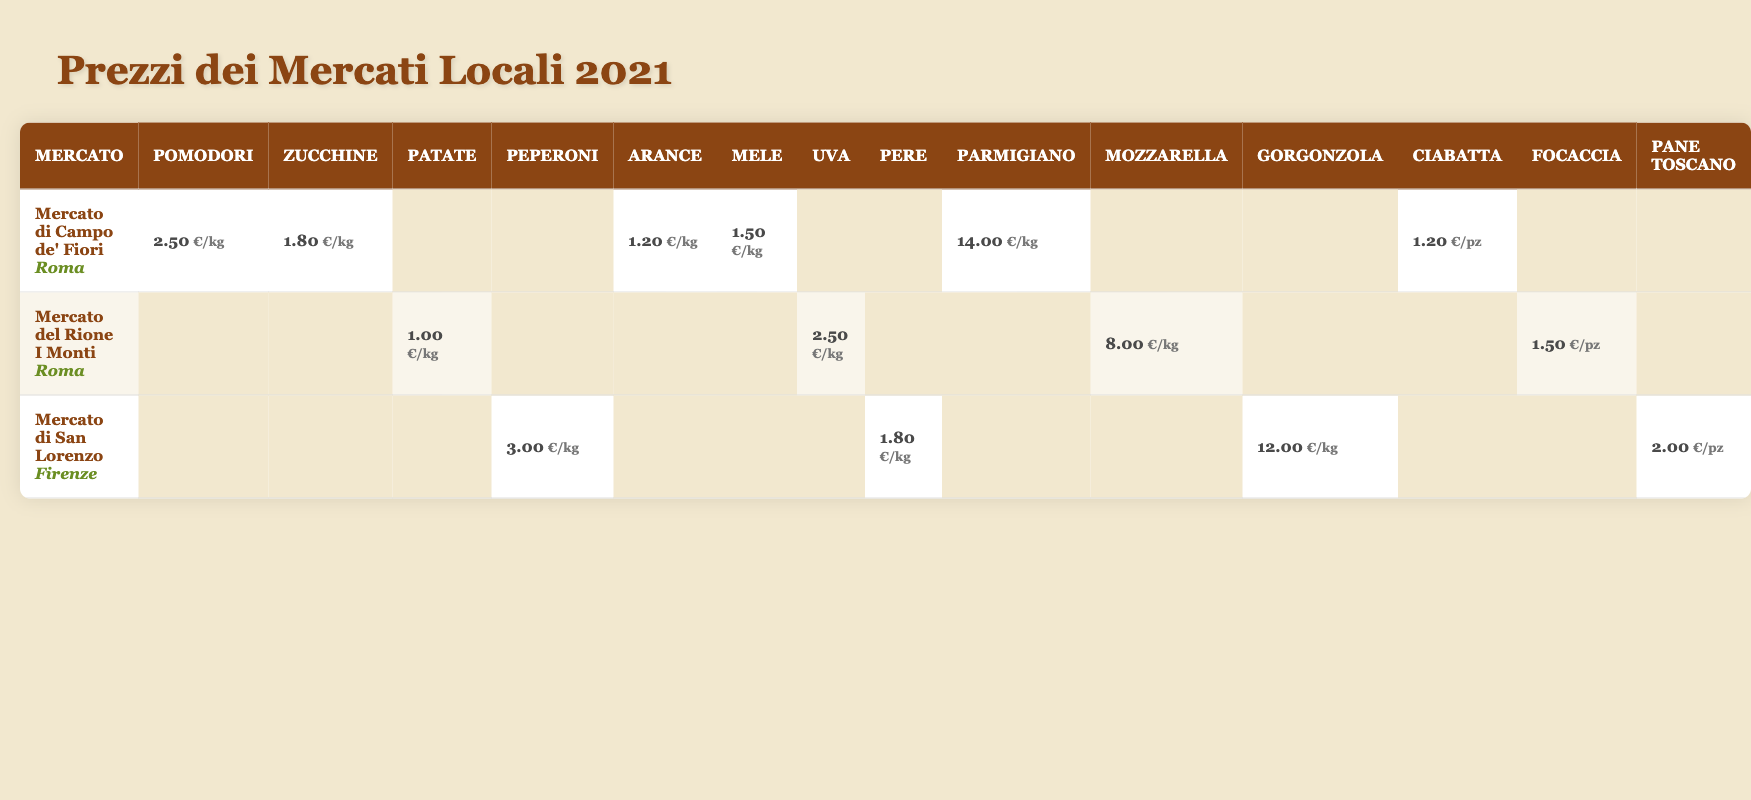What is the average price of tomatoes at the local markets? The table shows the price of tomatoes from two markets: Mercato di Campo de' Fiori at €2.50/kg and no price listed for Mercato del Rione I Monti and Mercato di San Lorenzo. The only price for tomatoes is from the Campo de' Fiori market. Thus, the average price remains €2.50.
Answer: €2.50 Which market has the highest price for cheese? The cheese prices listed are Parmesan at €14.00/kg, Mozzarella at €8.00/kg, and Gorgonzola at €12.00/kg. The highest price is Parmesan at the Mercato di Campo de' Fiori.
Answer: Mercato di Campo de' Fiori What is the price of pears at the different markets? Pears are only listed at the Mercato di San Lorenzo for €1.80/kg, while there's no price listed for the other two markets.
Answer: €1.80/kg (only at Mercato di San Lorenzo) Is the price of focaccia higher than ciabatta? Focaccia is priced at €1.50 per loaf and ciabatta is €1.20 per loaf. Since €1.50 is greater than €1.20, focaccia is more expensive.
Answer: Yes Which market offers the cheapest vegetables? From the table, Mercato del Rione I Monti offers potatoes at €1.00/kg, which appears to be the lowest price compared to other lists.
Answer: Mercato del Rione I Monti What is the combined price of all fruits available in Mercato di Campo de' Fiori? In Mercato di Campo de' Fiori, oranges are €1.20/kg and apples are €1.50/kg. The combined price is €1.20 + €1.50 = €2.70/kg.
Answer: €2.70/kg Does the Mercato di San Lorenzo have any bread available? The table indicates that Mercato di San Lorenzo has Toscano bread listed at €2.00 per loaf, confirming that they do have bread available.
Answer: Yes How much more do bell peppers cost compared to potatoes? Bell peppers are priced at €3.00/kg while potatoes cost €1.00/kg. The difference is €3.00 - €1.00 = €2.00. Bell peppers cost €2.00 more than potatoes.
Answer: €2.00 What is the most expensive fruit and its market? Grapes at €2.50/kg from Mercato del Rione I Monti are the most expensive fruit listed in the table.
Answer: Grapes at Mercato del Rione I Monti What is the total cost of cheese at the three markets? The cheese prices are Parmesan €14.00, Mozzarella €8.00, and Gorgonzola €12.00. The total is €14.00 + €8.00 + €12.00 = €34.00.
Answer: €34.00 